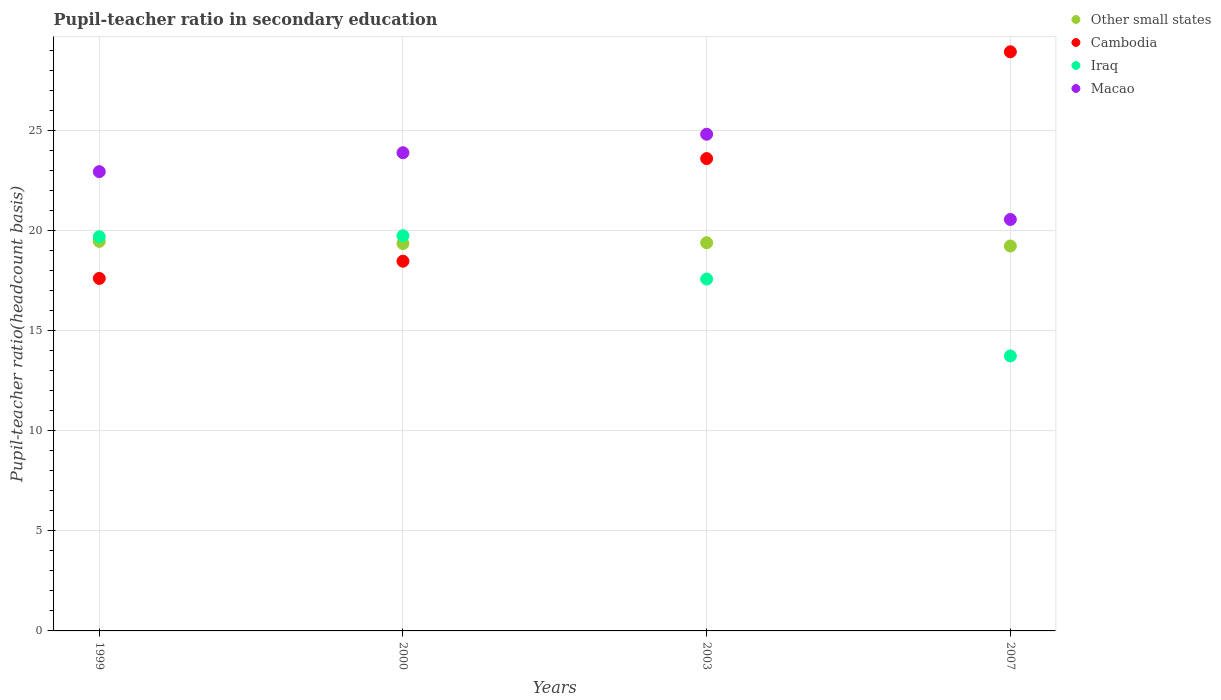What is the pupil-teacher ratio in secondary education in Other small states in 2007?
Your answer should be compact. 19.22. Across all years, what is the maximum pupil-teacher ratio in secondary education in Other small states?
Your response must be concise. 19.45. Across all years, what is the minimum pupil-teacher ratio in secondary education in Other small states?
Your answer should be very brief. 19.22. In which year was the pupil-teacher ratio in secondary education in Macao minimum?
Provide a short and direct response. 2007. What is the total pupil-teacher ratio in secondary education in Iraq in the graph?
Make the answer very short. 70.73. What is the difference between the pupil-teacher ratio in secondary education in Iraq in 1999 and that in 2000?
Your response must be concise. -0.05. What is the difference between the pupil-teacher ratio in secondary education in Other small states in 2003 and the pupil-teacher ratio in secondary education in Iraq in 1999?
Offer a terse response. -0.3. What is the average pupil-teacher ratio in secondary education in Macao per year?
Provide a short and direct response. 23.04. In the year 2003, what is the difference between the pupil-teacher ratio in secondary education in Macao and pupil-teacher ratio in secondary education in Other small states?
Offer a terse response. 5.42. In how many years, is the pupil-teacher ratio in secondary education in Macao greater than 7?
Make the answer very short. 4. What is the ratio of the pupil-teacher ratio in secondary education in Other small states in 2003 to that in 2007?
Offer a very short reply. 1.01. Is the pupil-teacher ratio in secondary education in Cambodia in 2000 less than that in 2003?
Your answer should be compact. Yes. What is the difference between the highest and the second highest pupil-teacher ratio in secondary education in Iraq?
Keep it short and to the point. 0.05. What is the difference between the highest and the lowest pupil-teacher ratio in secondary education in Macao?
Your answer should be very brief. 4.26. In how many years, is the pupil-teacher ratio in secondary education in Iraq greater than the average pupil-teacher ratio in secondary education in Iraq taken over all years?
Ensure brevity in your answer.  2. Is it the case that in every year, the sum of the pupil-teacher ratio in secondary education in Other small states and pupil-teacher ratio in secondary education in Iraq  is greater than the pupil-teacher ratio in secondary education in Cambodia?
Your answer should be very brief. Yes. Is the pupil-teacher ratio in secondary education in Cambodia strictly less than the pupil-teacher ratio in secondary education in Macao over the years?
Your answer should be very brief. No. How many dotlines are there?
Give a very brief answer. 4. How many years are there in the graph?
Your answer should be compact. 4. Are the values on the major ticks of Y-axis written in scientific E-notation?
Ensure brevity in your answer.  No. Where does the legend appear in the graph?
Your answer should be compact. Top right. How are the legend labels stacked?
Offer a terse response. Vertical. What is the title of the graph?
Ensure brevity in your answer.  Pupil-teacher ratio in secondary education. What is the label or title of the Y-axis?
Ensure brevity in your answer.  Pupil-teacher ratio(headcount basis). What is the Pupil-teacher ratio(headcount basis) in Other small states in 1999?
Provide a succinct answer. 19.45. What is the Pupil-teacher ratio(headcount basis) in Cambodia in 1999?
Provide a short and direct response. 17.6. What is the Pupil-teacher ratio(headcount basis) in Iraq in 1999?
Your response must be concise. 19.69. What is the Pupil-teacher ratio(headcount basis) in Macao in 1999?
Provide a succinct answer. 22.94. What is the Pupil-teacher ratio(headcount basis) in Other small states in 2000?
Provide a short and direct response. 19.34. What is the Pupil-teacher ratio(headcount basis) of Cambodia in 2000?
Provide a succinct answer. 18.46. What is the Pupil-teacher ratio(headcount basis) in Iraq in 2000?
Offer a very short reply. 19.74. What is the Pupil-teacher ratio(headcount basis) of Macao in 2000?
Offer a terse response. 23.88. What is the Pupil-teacher ratio(headcount basis) of Other small states in 2003?
Provide a succinct answer. 19.39. What is the Pupil-teacher ratio(headcount basis) of Cambodia in 2003?
Your answer should be compact. 23.59. What is the Pupil-teacher ratio(headcount basis) in Iraq in 2003?
Offer a very short reply. 17.57. What is the Pupil-teacher ratio(headcount basis) in Macao in 2003?
Offer a very short reply. 24.8. What is the Pupil-teacher ratio(headcount basis) in Other small states in 2007?
Your response must be concise. 19.22. What is the Pupil-teacher ratio(headcount basis) in Cambodia in 2007?
Provide a succinct answer. 28.92. What is the Pupil-teacher ratio(headcount basis) of Iraq in 2007?
Your response must be concise. 13.73. What is the Pupil-teacher ratio(headcount basis) in Macao in 2007?
Offer a very short reply. 20.55. Across all years, what is the maximum Pupil-teacher ratio(headcount basis) in Other small states?
Your answer should be very brief. 19.45. Across all years, what is the maximum Pupil-teacher ratio(headcount basis) in Cambodia?
Provide a succinct answer. 28.92. Across all years, what is the maximum Pupil-teacher ratio(headcount basis) of Iraq?
Give a very brief answer. 19.74. Across all years, what is the maximum Pupil-teacher ratio(headcount basis) in Macao?
Offer a very short reply. 24.8. Across all years, what is the minimum Pupil-teacher ratio(headcount basis) of Other small states?
Give a very brief answer. 19.22. Across all years, what is the minimum Pupil-teacher ratio(headcount basis) of Cambodia?
Offer a terse response. 17.6. Across all years, what is the minimum Pupil-teacher ratio(headcount basis) in Iraq?
Your response must be concise. 13.73. Across all years, what is the minimum Pupil-teacher ratio(headcount basis) of Macao?
Provide a succinct answer. 20.55. What is the total Pupil-teacher ratio(headcount basis) of Other small states in the graph?
Provide a short and direct response. 77.41. What is the total Pupil-teacher ratio(headcount basis) in Cambodia in the graph?
Your response must be concise. 88.58. What is the total Pupil-teacher ratio(headcount basis) in Iraq in the graph?
Provide a succinct answer. 70.73. What is the total Pupil-teacher ratio(headcount basis) in Macao in the graph?
Your answer should be very brief. 92.17. What is the difference between the Pupil-teacher ratio(headcount basis) of Other small states in 1999 and that in 2000?
Your response must be concise. 0.11. What is the difference between the Pupil-teacher ratio(headcount basis) of Cambodia in 1999 and that in 2000?
Provide a short and direct response. -0.86. What is the difference between the Pupil-teacher ratio(headcount basis) in Iraq in 1999 and that in 2000?
Keep it short and to the point. -0.05. What is the difference between the Pupil-teacher ratio(headcount basis) in Macao in 1999 and that in 2000?
Provide a succinct answer. -0.94. What is the difference between the Pupil-teacher ratio(headcount basis) of Other small states in 1999 and that in 2003?
Provide a succinct answer. 0.07. What is the difference between the Pupil-teacher ratio(headcount basis) in Cambodia in 1999 and that in 2003?
Provide a succinct answer. -5.99. What is the difference between the Pupil-teacher ratio(headcount basis) in Iraq in 1999 and that in 2003?
Provide a short and direct response. 2.12. What is the difference between the Pupil-teacher ratio(headcount basis) of Macao in 1999 and that in 2003?
Your answer should be compact. -1.87. What is the difference between the Pupil-teacher ratio(headcount basis) in Other small states in 1999 and that in 2007?
Make the answer very short. 0.23. What is the difference between the Pupil-teacher ratio(headcount basis) of Cambodia in 1999 and that in 2007?
Provide a succinct answer. -11.32. What is the difference between the Pupil-teacher ratio(headcount basis) in Iraq in 1999 and that in 2007?
Your answer should be very brief. 5.95. What is the difference between the Pupil-teacher ratio(headcount basis) in Macao in 1999 and that in 2007?
Make the answer very short. 2.39. What is the difference between the Pupil-teacher ratio(headcount basis) in Other small states in 2000 and that in 2003?
Provide a succinct answer. -0.04. What is the difference between the Pupil-teacher ratio(headcount basis) of Cambodia in 2000 and that in 2003?
Give a very brief answer. -5.12. What is the difference between the Pupil-teacher ratio(headcount basis) in Iraq in 2000 and that in 2003?
Keep it short and to the point. 2.16. What is the difference between the Pupil-teacher ratio(headcount basis) of Macao in 2000 and that in 2003?
Offer a very short reply. -0.92. What is the difference between the Pupil-teacher ratio(headcount basis) in Other small states in 2000 and that in 2007?
Give a very brief answer. 0.12. What is the difference between the Pupil-teacher ratio(headcount basis) in Cambodia in 2000 and that in 2007?
Ensure brevity in your answer.  -10.46. What is the difference between the Pupil-teacher ratio(headcount basis) of Iraq in 2000 and that in 2007?
Offer a terse response. 6. What is the difference between the Pupil-teacher ratio(headcount basis) in Macao in 2000 and that in 2007?
Give a very brief answer. 3.33. What is the difference between the Pupil-teacher ratio(headcount basis) of Other small states in 2003 and that in 2007?
Ensure brevity in your answer.  0.16. What is the difference between the Pupil-teacher ratio(headcount basis) in Cambodia in 2003 and that in 2007?
Provide a succinct answer. -5.33. What is the difference between the Pupil-teacher ratio(headcount basis) of Iraq in 2003 and that in 2007?
Offer a very short reply. 3.84. What is the difference between the Pupil-teacher ratio(headcount basis) of Macao in 2003 and that in 2007?
Your response must be concise. 4.26. What is the difference between the Pupil-teacher ratio(headcount basis) in Other small states in 1999 and the Pupil-teacher ratio(headcount basis) in Cambodia in 2000?
Offer a very short reply. 0.99. What is the difference between the Pupil-teacher ratio(headcount basis) in Other small states in 1999 and the Pupil-teacher ratio(headcount basis) in Iraq in 2000?
Your response must be concise. -0.28. What is the difference between the Pupil-teacher ratio(headcount basis) of Other small states in 1999 and the Pupil-teacher ratio(headcount basis) of Macao in 2000?
Make the answer very short. -4.43. What is the difference between the Pupil-teacher ratio(headcount basis) in Cambodia in 1999 and the Pupil-teacher ratio(headcount basis) in Iraq in 2000?
Offer a terse response. -2.13. What is the difference between the Pupil-teacher ratio(headcount basis) in Cambodia in 1999 and the Pupil-teacher ratio(headcount basis) in Macao in 2000?
Your response must be concise. -6.28. What is the difference between the Pupil-teacher ratio(headcount basis) of Iraq in 1999 and the Pupil-teacher ratio(headcount basis) of Macao in 2000?
Provide a short and direct response. -4.19. What is the difference between the Pupil-teacher ratio(headcount basis) in Other small states in 1999 and the Pupil-teacher ratio(headcount basis) in Cambodia in 2003?
Offer a very short reply. -4.14. What is the difference between the Pupil-teacher ratio(headcount basis) in Other small states in 1999 and the Pupil-teacher ratio(headcount basis) in Iraq in 2003?
Give a very brief answer. 1.88. What is the difference between the Pupil-teacher ratio(headcount basis) of Other small states in 1999 and the Pupil-teacher ratio(headcount basis) of Macao in 2003?
Give a very brief answer. -5.35. What is the difference between the Pupil-teacher ratio(headcount basis) of Cambodia in 1999 and the Pupil-teacher ratio(headcount basis) of Iraq in 2003?
Your answer should be very brief. 0.03. What is the difference between the Pupil-teacher ratio(headcount basis) in Cambodia in 1999 and the Pupil-teacher ratio(headcount basis) in Macao in 2003?
Provide a succinct answer. -7.2. What is the difference between the Pupil-teacher ratio(headcount basis) in Iraq in 1999 and the Pupil-teacher ratio(headcount basis) in Macao in 2003?
Provide a succinct answer. -5.12. What is the difference between the Pupil-teacher ratio(headcount basis) of Other small states in 1999 and the Pupil-teacher ratio(headcount basis) of Cambodia in 2007?
Your answer should be very brief. -9.47. What is the difference between the Pupil-teacher ratio(headcount basis) of Other small states in 1999 and the Pupil-teacher ratio(headcount basis) of Iraq in 2007?
Give a very brief answer. 5.72. What is the difference between the Pupil-teacher ratio(headcount basis) in Other small states in 1999 and the Pupil-teacher ratio(headcount basis) in Macao in 2007?
Ensure brevity in your answer.  -1.09. What is the difference between the Pupil-teacher ratio(headcount basis) in Cambodia in 1999 and the Pupil-teacher ratio(headcount basis) in Iraq in 2007?
Offer a terse response. 3.87. What is the difference between the Pupil-teacher ratio(headcount basis) in Cambodia in 1999 and the Pupil-teacher ratio(headcount basis) in Macao in 2007?
Give a very brief answer. -2.94. What is the difference between the Pupil-teacher ratio(headcount basis) in Iraq in 1999 and the Pupil-teacher ratio(headcount basis) in Macao in 2007?
Ensure brevity in your answer.  -0.86. What is the difference between the Pupil-teacher ratio(headcount basis) of Other small states in 2000 and the Pupil-teacher ratio(headcount basis) of Cambodia in 2003?
Offer a very short reply. -4.24. What is the difference between the Pupil-teacher ratio(headcount basis) of Other small states in 2000 and the Pupil-teacher ratio(headcount basis) of Iraq in 2003?
Offer a terse response. 1.77. What is the difference between the Pupil-teacher ratio(headcount basis) of Other small states in 2000 and the Pupil-teacher ratio(headcount basis) of Macao in 2003?
Provide a short and direct response. -5.46. What is the difference between the Pupil-teacher ratio(headcount basis) in Cambodia in 2000 and the Pupil-teacher ratio(headcount basis) in Iraq in 2003?
Your answer should be compact. 0.89. What is the difference between the Pupil-teacher ratio(headcount basis) in Cambodia in 2000 and the Pupil-teacher ratio(headcount basis) in Macao in 2003?
Make the answer very short. -6.34. What is the difference between the Pupil-teacher ratio(headcount basis) in Iraq in 2000 and the Pupil-teacher ratio(headcount basis) in Macao in 2003?
Make the answer very short. -5.07. What is the difference between the Pupil-teacher ratio(headcount basis) in Other small states in 2000 and the Pupil-teacher ratio(headcount basis) in Cambodia in 2007?
Your answer should be compact. -9.58. What is the difference between the Pupil-teacher ratio(headcount basis) of Other small states in 2000 and the Pupil-teacher ratio(headcount basis) of Iraq in 2007?
Offer a very short reply. 5.61. What is the difference between the Pupil-teacher ratio(headcount basis) of Other small states in 2000 and the Pupil-teacher ratio(headcount basis) of Macao in 2007?
Your answer should be compact. -1.2. What is the difference between the Pupil-teacher ratio(headcount basis) in Cambodia in 2000 and the Pupil-teacher ratio(headcount basis) in Iraq in 2007?
Your answer should be very brief. 4.73. What is the difference between the Pupil-teacher ratio(headcount basis) of Cambodia in 2000 and the Pupil-teacher ratio(headcount basis) of Macao in 2007?
Give a very brief answer. -2.08. What is the difference between the Pupil-teacher ratio(headcount basis) in Iraq in 2000 and the Pupil-teacher ratio(headcount basis) in Macao in 2007?
Your answer should be very brief. -0.81. What is the difference between the Pupil-teacher ratio(headcount basis) of Other small states in 2003 and the Pupil-teacher ratio(headcount basis) of Cambodia in 2007?
Make the answer very short. -9.54. What is the difference between the Pupil-teacher ratio(headcount basis) in Other small states in 2003 and the Pupil-teacher ratio(headcount basis) in Iraq in 2007?
Give a very brief answer. 5.65. What is the difference between the Pupil-teacher ratio(headcount basis) of Other small states in 2003 and the Pupil-teacher ratio(headcount basis) of Macao in 2007?
Keep it short and to the point. -1.16. What is the difference between the Pupil-teacher ratio(headcount basis) in Cambodia in 2003 and the Pupil-teacher ratio(headcount basis) in Iraq in 2007?
Offer a terse response. 9.86. What is the difference between the Pupil-teacher ratio(headcount basis) in Cambodia in 2003 and the Pupil-teacher ratio(headcount basis) in Macao in 2007?
Offer a terse response. 3.04. What is the difference between the Pupil-teacher ratio(headcount basis) of Iraq in 2003 and the Pupil-teacher ratio(headcount basis) of Macao in 2007?
Offer a terse response. -2.98. What is the average Pupil-teacher ratio(headcount basis) of Other small states per year?
Make the answer very short. 19.35. What is the average Pupil-teacher ratio(headcount basis) in Cambodia per year?
Provide a succinct answer. 22.14. What is the average Pupil-teacher ratio(headcount basis) of Iraq per year?
Offer a terse response. 17.68. What is the average Pupil-teacher ratio(headcount basis) of Macao per year?
Provide a succinct answer. 23.04. In the year 1999, what is the difference between the Pupil-teacher ratio(headcount basis) of Other small states and Pupil-teacher ratio(headcount basis) of Cambodia?
Your answer should be very brief. 1.85. In the year 1999, what is the difference between the Pupil-teacher ratio(headcount basis) in Other small states and Pupil-teacher ratio(headcount basis) in Iraq?
Provide a short and direct response. -0.23. In the year 1999, what is the difference between the Pupil-teacher ratio(headcount basis) in Other small states and Pupil-teacher ratio(headcount basis) in Macao?
Your answer should be very brief. -3.48. In the year 1999, what is the difference between the Pupil-teacher ratio(headcount basis) in Cambodia and Pupil-teacher ratio(headcount basis) in Iraq?
Make the answer very short. -2.08. In the year 1999, what is the difference between the Pupil-teacher ratio(headcount basis) in Cambodia and Pupil-teacher ratio(headcount basis) in Macao?
Your response must be concise. -5.33. In the year 1999, what is the difference between the Pupil-teacher ratio(headcount basis) of Iraq and Pupil-teacher ratio(headcount basis) of Macao?
Offer a terse response. -3.25. In the year 2000, what is the difference between the Pupil-teacher ratio(headcount basis) of Other small states and Pupil-teacher ratio(headcount basis) of Cambodia?
Your answer should be very brief. 0.88. In the year 2000, what is the difference between the Pupil-teacher ratio(headcount basis) of Other small states and Pupil-teacher ratio(headcount basis) of Iraq?
Make the answer very short. -0.39. In the year 2000, what is the difference between the Pupil-teacher ratio(headcount basis) in Other small states and Pupil-teacher ratio(headcount basis) in Macao?
Your answer should be very brief. -4.54. In the year 2000, what is the difference between the Pupil-teacher ratio(headcount basis) of Cambodia and Pupil-teacher ratio(headcount basis) of Iraq?
Your answer should be very brief. -1.27. In the year 2000, what is the difference between the Pupil-teacher ratio(headcount basis) of Cambodia and Pupil-teacher ratio(headcount basis) of Macao?
Make the answer very short. -5.42. In the year 2000, what is the difference between the Pupil-teacher ratio(headcount basis) in Iraq and Pupil-teacher ratio(headcount basis) in Macao?
Provide a short and direct response. -4.15. In the year 2003, what is the difference between the Pupil-teacher ratio(headcount basis) in Other small states and Pupil-teacher ratio(headcount basis) in Cambodia?
Provide a short and direct response. -4.2. In the year 2003, what is the difference between the Pupil-teacher ratio(headcount basis) in Other small states and Pupil-teacher ratio(headcount basis) in Iraq?
Your response must be concise. 1.81. In the year 2003, what is the difference between the Pupil-teacher ratio(headcount basis) of Other small states and Pupil-teacher ratio(headcount basis) of Macao?
Your response must be concise. -5.42. In the year 2003, what is the difference between the Pupil-teacher ratio(headcount basis) of Cambodia and Pupil-teacher ratio(headcount basis) of Iraq?
Offer a terse response. 6.02. In the year 2003, what is the difference between the Pupil-teacher ratio(headcount basis) in Cambodia and Pupil-teacher ratio(headcount basis) in Macao?
Your answer should be compact. -1.22. In the year 2003, what is the difference between the Pupil-teacher ratio(headcount basis) in Iraq and Pupil-teacher ratio(headcount basis) in Macao?
Your answer should be very brief. -7.23. In the year 2007, what is the difference between the Pupil-teacher ratio(headcount basis) of Other small states and Pupil-teacher ratio(headcount basis) of Cambodia?
Your answer should be compact. -9.7. In the year 2007, what is the difference between the Pupil-teacher ratio(headcount basis) of Other small states and Pupil-teacher ratio(headcount basis) of Iraq?
Your answer should be compact. 5.49. In the year 2007, what is the difference between the Pupil-teacher ratio(headcount basis) in Other small states and Pupil-teacher ratio(headcount basis) in Macao?
Provide a short and direct response. -1.33. In the year 2007, what is the difference between the Pupil-teacher ratio(headcount basis) in Cambodia and Pupil-teacher ratio(headcount basis) in Iraq?
Offer a terse response. 15.19. In the year 2007, what is the difference between the Pupil-teacher ratio(headcount basis) in Cambodia and Pupil-teacher ratio(headcount basis) in Macao?
Make the answer very short. 8.37. In the year 2007, what is the difference between the Pupil-teacher ratio(headcount basis) in Iraq and Pupil-teacher ratio(headcount basis) in Macao?
Your response must be concise. -6.81. What is the ratio of the Pupil-teacher ratio(headcount basis) of Other small states in 1999 to that in 2000?
Offer a terse response. 1.01. What is the ratio of the Pupil-teacher ratio(headcount basis) of Cambodia in 1999 to that in 2000?
Offer a very short reply. 0.95. What is the ratio of the Pupil-teacher ratio(headcount basis) of Macao in 1999 to that in 2000?
Your answer should be very brief. 0.96. What is the ratio of the Pupil-teacher ratio(headcount basis) of Other small states in 1999 to that in 2003?
Offer a terse response. 1. What is the ratio of the Pupil-teacher ratio(headcount basis) in Cambodia in 1999 to that in 2003?
Provide a short and direct response. 0.75. What is the ratio of the Pupil-teacher ratio(headcount basis) of Iraq in 1999 to that in 2003?
Give a very brief answer. 1.12. What is the ratio of the Pupil-teacher ratio(headcount basis) of Macao in 1999 to that in 2003?
Offer a very short reply. 0.92. What is the ratio of the Pupil-teacher ratio(headcount basis) in Cambodia in 1999 to that in 2007?
Your answer should be compact. 0.61. What is the ratio of the Pupil-teacher ratio(headcount basis) in Iraq in 1999 to that in 2007?
Offer a very short reply. 1.43. What is the ratio of the Pupil-teacher ratio(headcount basis) of Macao in 1999 to that in 2007?
Offer a terse response. 1.12. What is the ratio of the Pupil-teacher ratio(headcount basis) in Other small states in 2000 to that in 2003?
Your response must be concise. 1. What is the ratio of the Pupil-teacher ratio(headcount basis) of Cambodia in 2000 to that in 2003?
Provide a succinct answer. 0.78. What is the ratio of the Pupil-teacher ratio(headcount basis) in Iraq in 2000 to that in 2003?
Offer a terse response. 1.12. What is the ratio of the Pupil-teacher ratio(headcount basis) in Macao in 2000 to that in 2003?
Your answer should be very brief. 0.96. What is the ratio of the Pupil-teacher ratio(headcount basis) of Other small states in 2000 to that in 2007?
Offer a very short reply. 1.01. What is the ratio of the Pupil-teacher ratio(headcount basis) in Cambodia in 2000 to that in 2007?
Provide a succinct answer. 0.64. What is the ratio of the Pupil-teacher ratio(headcount basis) in Iraq in 2000 to that in 2007?
Ensure brevity in your answer.  1.44. What is the ratio of the Pupil-teacher ratio(headcount basis) in Macao in 2000 to that in 2007?
Offer a very short reply. 1.16. What is the ratio of the Pupil-teacher ratio(headcount basis) of Other small states in 2003 to that in 2007?
Your answer should be compact. 1.01. What is the ratio of the Pupil-teacher ratio(headcount basis) in Cambodia in 2003 to that in 2007?
Provide a succinct answer. 0.82. What is the ratio of the Pupil-teacher ratio(headcount basis) in Iraq in 2003 to that in 2007?
Offer a very short reply. 1.28. What is the ratio of the Pupil-teacher ratio(headcount basis) of Macao in 2003 to that in 2007?
Your response must be concise. 1.21. What is the difference between the highest and the second highest Pupil-teacher ratio(headcount basis) in Other small states?
Your answer should be compact. 0.07. What is the difference between the highest and the second highest Pupil-teacher ratio(headcount basis) of Cambodia?
Your answer should be very brief. 5.33. What is the difference between the highest and the second highest Pupil-teacher ratio(headcount basis) in Iraq?
Your answer should be compact. 0.05. What is the difference between the highest and the second highest Pupil-teacher ratio(headcount basis) in Macao?
Offer a very short reply. 0.92. What is the difference between the highest and the lowest Pupil-teacher ratio(headcount basis) of Other small states?
Your answer should be compact. 0.23. What is the difference between the highest and the lowest Pupil-teacher ratio(headcount basis) of Cambodia?
Make the answer very short. 11.32. What is the difference between the highest and the lowest Pupil-teacher ratio(headcount basis) of Iraq?
Make the answer very short. 6. What is the difference between the highest and the lowest Pupil-teacher ratio(headcount basis) of Macao?
Provide a short and direct response. 4.26. 